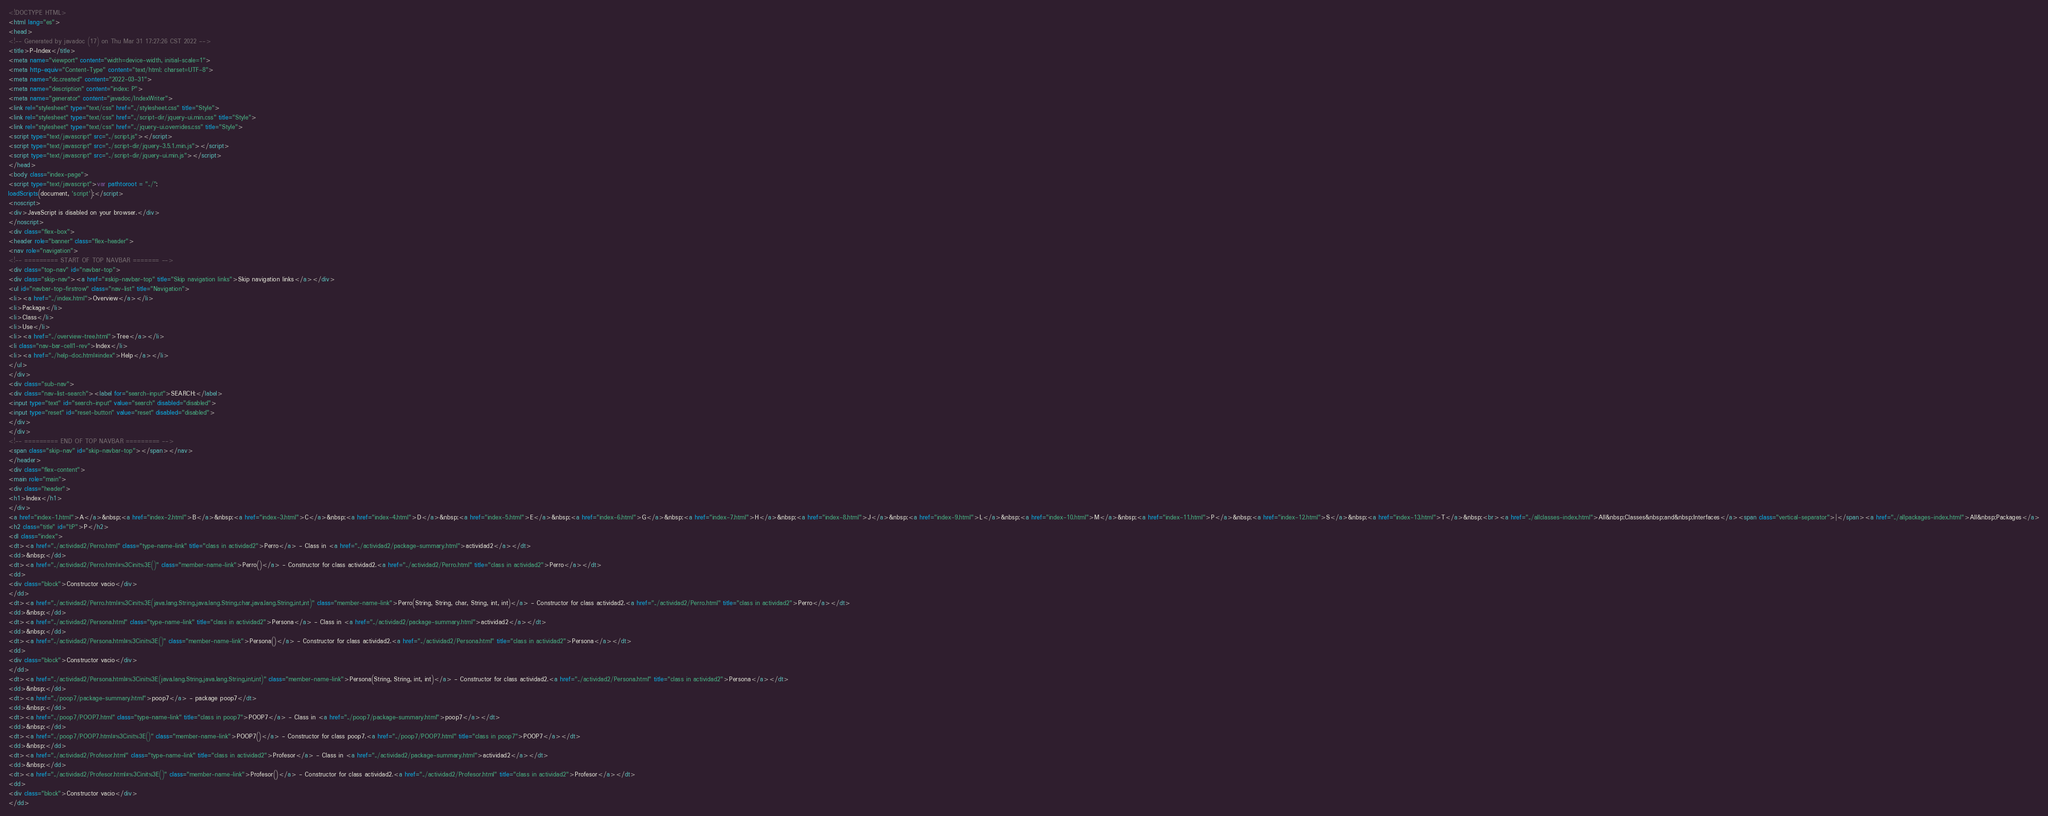<code> <loc_0><loc_0><loc_500><loc_500><_HTML_><!DOCTYPE HTML>
<html lang="es">
<head>
<!-- Generated by javadoc (17) on Thu Mar 31 17:27:26 CST 2022 -->
<title>P-Index</title>
<meta name="viewport" content="width=device-width, initial-scale=1">
<meta http-equiv="Content-Type" content="text/html; charset=UTF-8">
<meta name="dc.created" content="2022-03-31">
<meta name="description" content="index: P">
<meta name="generator" content="javadoc/IndexWriter">
<link rel="stylesheet" type="text/css" href="../stylesheet.css" title="Style">
<link rel="stylesheet" type="text/css" href="../script-dir/jquery-ui.min.css" title="Style">
<link rel="stylesheet" type="text/css" href="../jquery-ui.overrides.css" title="Style">
<script type="text/javascript" src="../script.js"></script>
<script type="text/javascript" src="../script-dir/jquery-3.5.1.min.js"></script>
<script type="text/javascript" src="../script-dir/jquery-ui.min.js"></script>
</head>
<body class="index-page">
<script type="text/javascript">var pathtoroot = "../";
loadScripts(document, 'script');</script>
<noscript>
<div>JavaScript is disabled on your browser.</div>
</noscript>
<div class="flex-box">
<header role="banner" class="flex-header">
<nav role="navigation">
<!-- ========= START OF TOP NAVBAR ======= -->
<div class="top-nav" id="navbar-top">
<div class="skip-nav"><a href="#skip-navbar-top" title="Skip navigation links">Skip navigation links</a></div>
<ul id="navbar-top-firstrow" class="nav-list" title="Navigation">
<li><a href="../index.html">Overview</a></li>
<li>Package</li>
<li>Class</li>
<li>Use</li>
<li><a href="../overview-tree.html">Tree</a></li>
<li class="nav-bar-cell1-rev">Index</li>
<li><a href="../help-doc.html#index">Help</a></li>
</ul>
</div>
<div class="sub-nav">
<div class="nav-list-search"><label for="search-input">SEARCH:</label>
<input type="text" id="search-input" value="search" disabled="disabled">
<input type="reset" id="reset-button" value="reset" disabled="disabled">
</div>
</div>
<!-- ========= END OF TOP NAVBAR ========= -->
<span class="skip-nav" id="skip-navbar-top"></span></nav>
</header>
<div class="flex-content">
<main role="main">
<div class="header">
<h1>Index</h1>
</div>
<a href="index-1.html">A</a>&nbsp;<a href="index-2.html">B</a>&nbsp;<a href="index-3.html">C</a>&nbsp;<a href="index-4.html">D</a>&nbsp;<a href="index-5.html">E</a>&nbsp;<a href="index-6.html">G</a>&nbsp;<a href="index-7.html">H</a>&nbsp;<a href="index-8.html">J</a>&nbsp;<a href="index-9.html">L</a>&nbsp;<a href="index-10.html">M</a>&nbsp;<a href="index-11.html">P</a>&nbsp;<a href="index-12.html">S</a>&nbsp;<a href="index-13.html">T</a>&nbsp;<br><a href="../allclasses-index.html">All&nbsp;Classes&nbsp;and&nbsp;Interfaces</a><span class="vertical-separator">|</span><a href="../allpackages-index.html">All&nbsp;Packages</a>
<h2 class="title" id="I:P">P</h2>
<dl class="index">
<dt><a href="../actividad2/Perro.html" class="type-name-link" title="class in actividad2">Perro</a> - Class in <a href="../actividad2/package-summary.html">actividad2</a></dt>
<dd>&nbsp;</dd>
<dt><a href="../actividad2/Perro.html#%3Cinit%3E()" class="member-name-link">Perro()</a> - Constructor for class actividad2.<a href="../actividad2/Perro.html" title="class in actividad2">Perro</a></dt>
<dd>
<div class="block">Constructor vacio</div>
</dd>
<dt><a href="../actividad2/Perro.html#%3Cinit%3E(java.lang.String,java.lang.String,char,java.lang.String,int,int)" class="member-name-link">Perro(String, String, char, String, int, int)</a> - Constructor for class actividad2.<a href="../actividad2/Perro.html" title="class in actividad2">Perro</a></dt>
<dd>&nbsp;</dd>
<dt><a href="../actividad2/Persona.html" class="type-name-link" title="class in actividad2">Persona</a> - Class in <a href="../actividad2/package-summary.html">actividad2</a></dt>
<dd>&nbsp;</dd>
<dt><a href="../actividad2/Persona.html#%3Cinit%3E()" class="member-name-link">Persona()</a> - Constructor for class actividad2.<a href="../actividad2/Persona.html" title="class in actividad2">Persona</a></dt>
<dd>
<div class="block">Constructor vacio</div>
</dd>
<dt><a href="../actividad2/Persona.html#%3Cinit%3E(java.lang.String,java.lang.String,int,int)" class="member-name-link">Persona(String, String, int, int)</a> - Constructor for class actividad2.<a href="../actividad2/Persona.html" title="class in actividad2">Persona</a></dt>
<dd>&nbsp;</dd>
<dt><a href="../poop7/package-summary.html">poop7</a> - package poop7</dt>
<dd>&nbsp;</dd>
<dt><a href="../poop7/POOP7.html" class="type-name-link" title="class in poop7">POOP7</a> - Class in <a href="../poop7/package-summary.html">poop7</a></dt>
<dd>&nbsp;</dd>
<dt><a href="../poop7/POOP7.html#%3Cinit%3E()" class="member-name-link">POOP7()</a> - Constructor for class poop7.<a href="../poop7/POOP7.html" title="class in poop7">POOP7</a></dt>
<dd>&nbsp;</dd>
<dt><a href="../actividad2/Profesor.html" class="type-name-link" title="class in actividad2">Profesor</a> - Class in <a href="../actividad2/package-summary.html">actividad2</a></dt>
<dd>&nbsp;</dd>
<dt><a href="../actividad2/Profesor.html#%3Cinit%3E()" class="member-name-link">Profesor()</a> - Constructor for class actividad2.<a href="../actividad2/Profesor.html" title="class in actividad2">Profesor</a></dt>
<dd>
<div class="block">Constructor vacio</div>
</dd></code> 